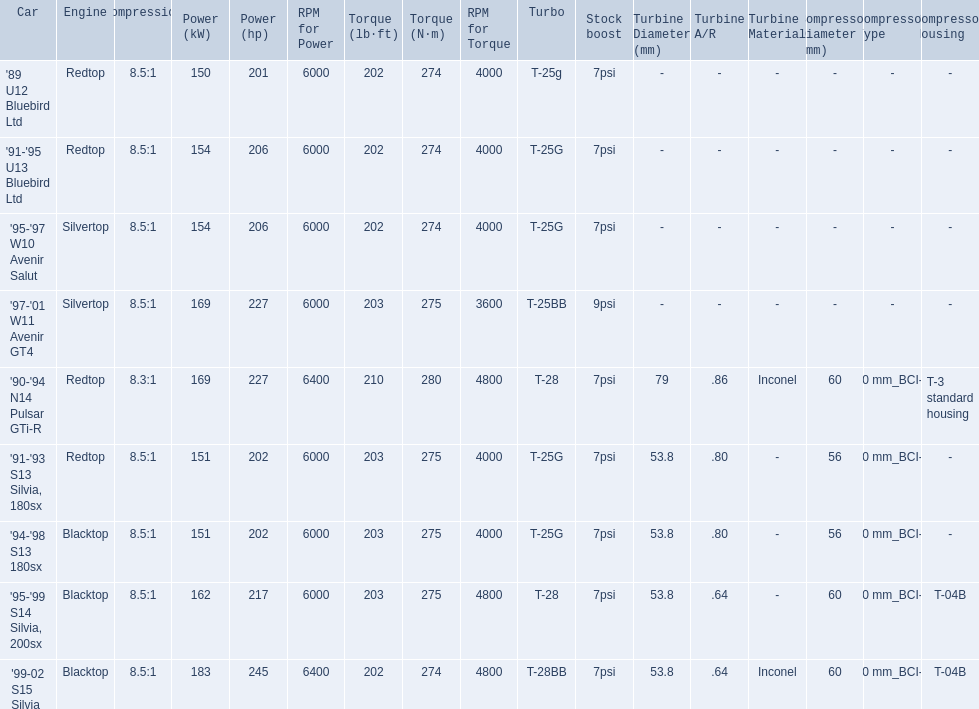What are all of the nissan cars? '89 U12 Bluebird Ltd, '91-'95 U13 Bluebird Ltd, '95-'97 W10 Avenir Salut, '97-'01 W11 Avenir GT4, '90-'94 N14 Pulsar GTi-R, '91-'93 S13 Silvia, 180sx, '94-'98 S13 180sx, '95-'99 S14 Silvia, 200sx, '99-02 S15 Silvia. Of these cars, which one is a '90-'94 n14 pulsar gti-r? '90-'94 N14 Pulsar GTi-R. What is the compression of this car? 8.3:1. 